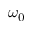<formula> <loc_0><loc_0><loc_500><loc_500>\omega _ { 0 }</formula> 